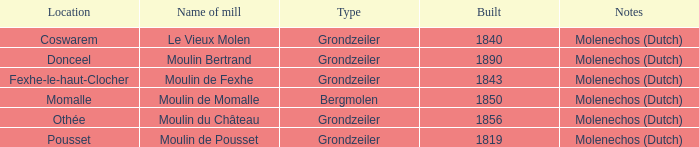What is the grondzeiler mill's name? Le Vieux Molen, Moulin Bertrand, Moulin de Fexhe, Moulin du Château, Moulin de Pousset. 